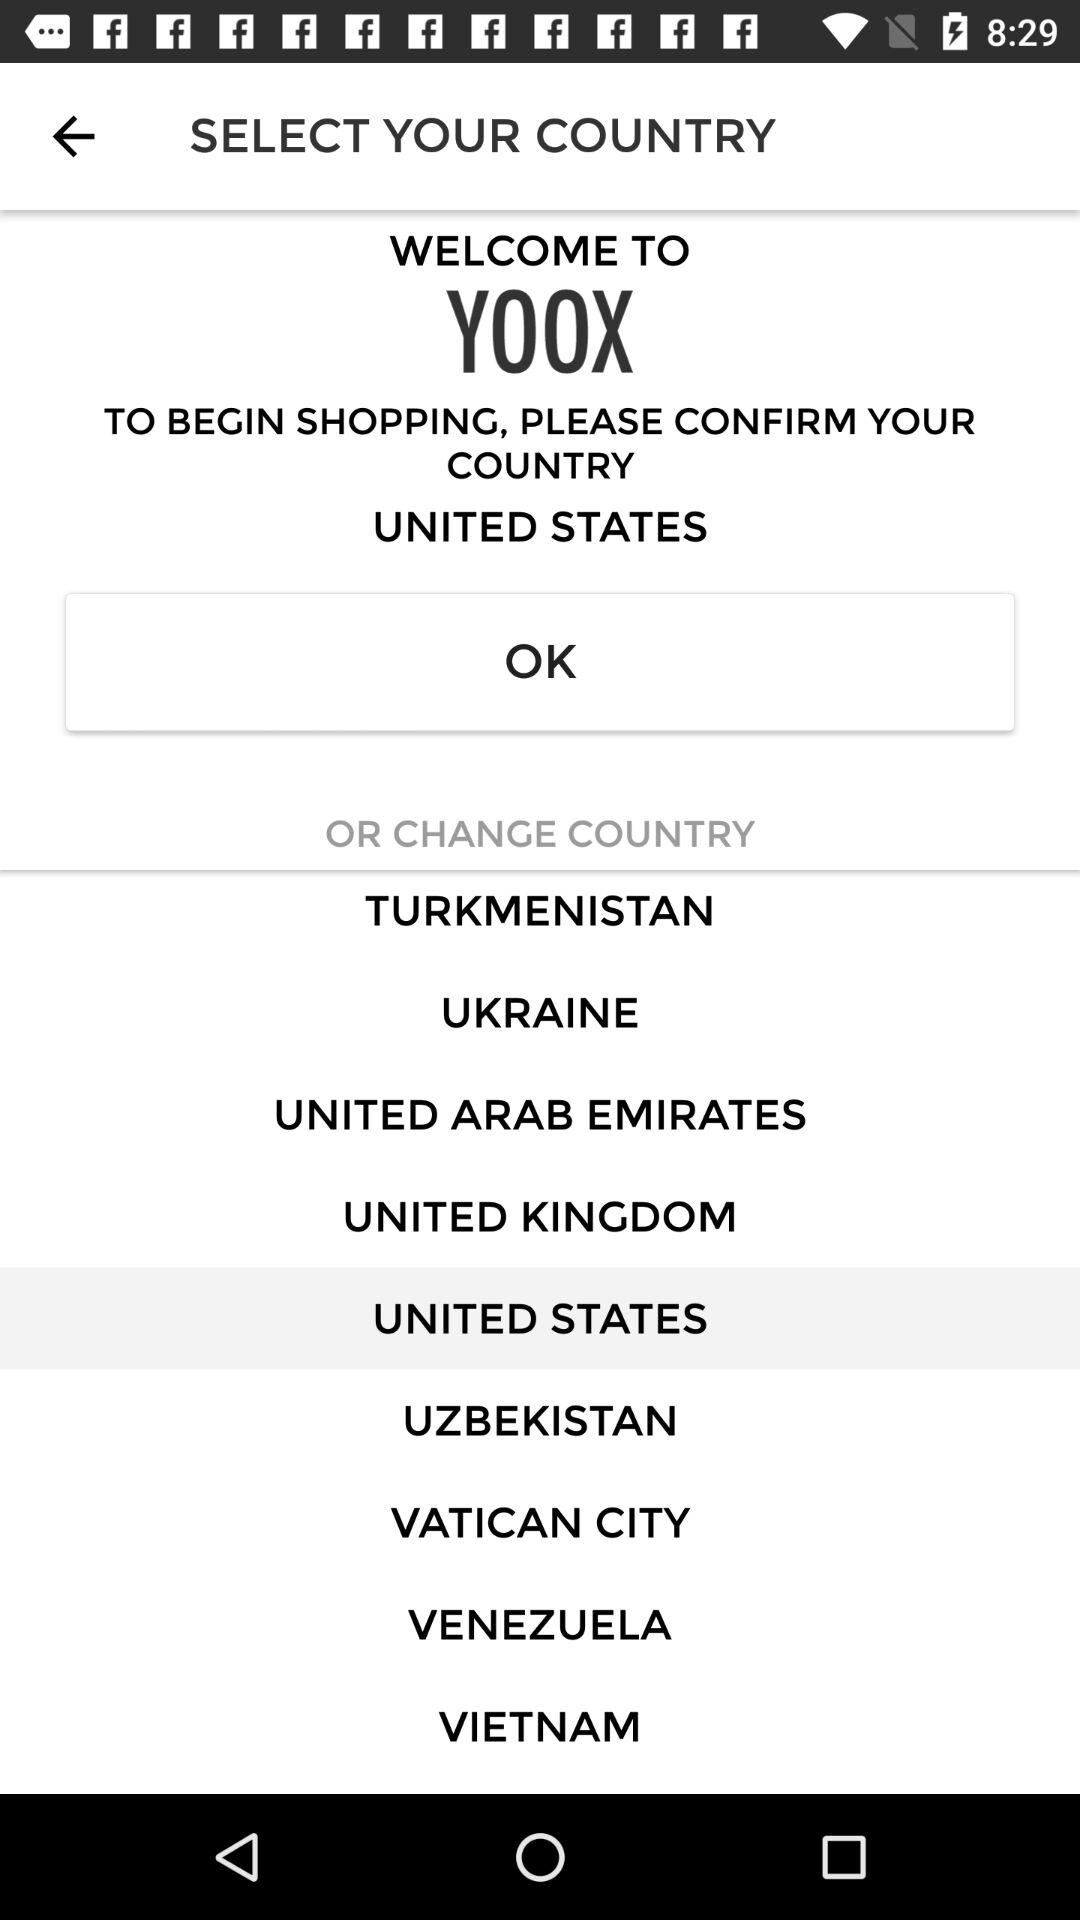What is the name of the application? The name of the application is "YOOX". 